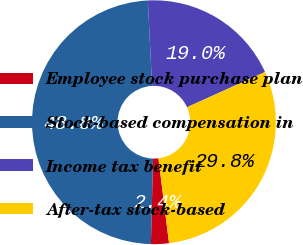Convert chart. <chart><loc_0><loc_0><loc_500><loc_500><pie_chart><fcel>Employee stock purchase plan<fcel>Stock-based compensation in<fcel>Income tax benefit<fcel>After-tax stock-based<nl><fcel>2.37%<fcel>48.81%<fcel>19.04%<fcel>29.78%<nl></chart> 